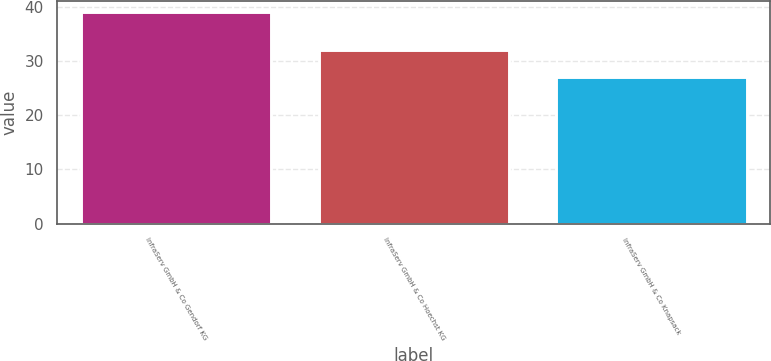Convert chart to OTSL. <chart><loc_0><loc_0><loc_500><loc_500><bar_chart><fcel>InfraServ GmbH & Co Gendorf KG<fcel>InfraServ GmbH & Co Hoechst KG<fcel>InfraServ GmbH & Co Knapsack<nl><fcel>39<fcel>32<fcel>27<nl></chart> 